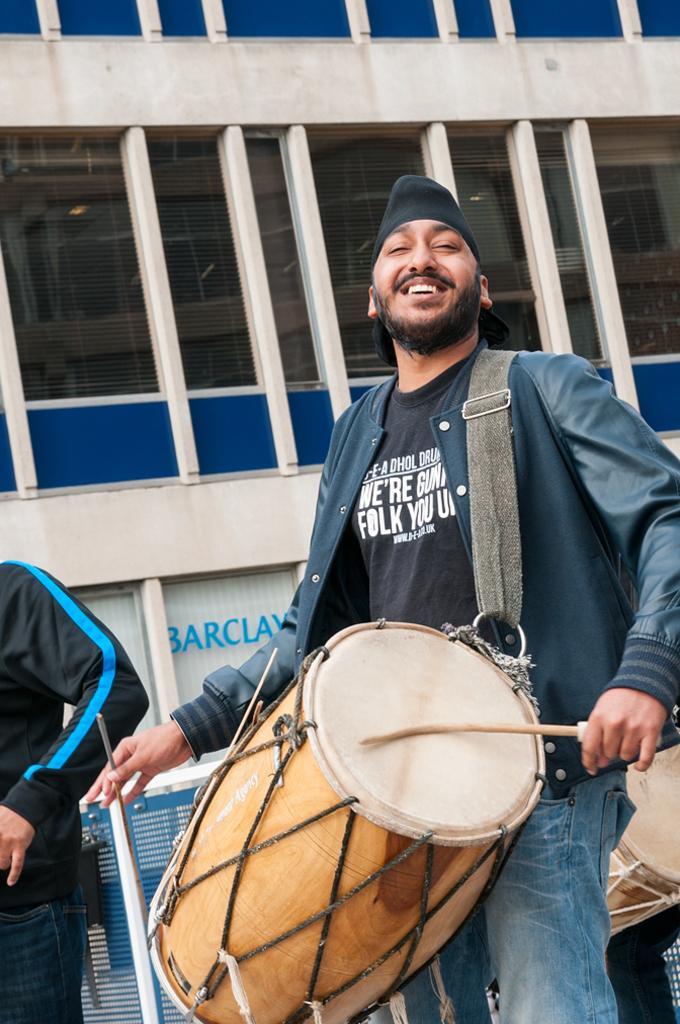Please provide a concise description of this image. In the picture we can see one man holding a drum and playing it, beside the man there is one more person standing. In the background we can find a building of pillars, some name on it barclay. 